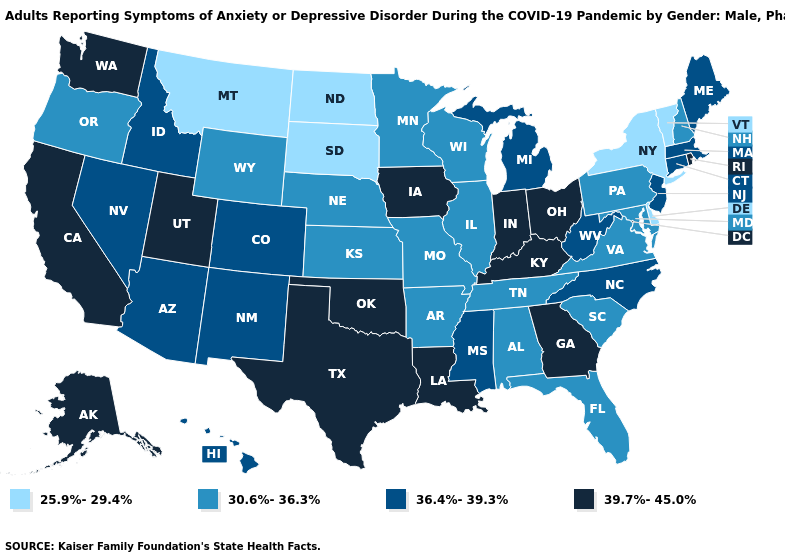What is the value of Florida?
Concise answer only. 30.6%-36.3%. What is the value of Nevada?
Write a very short answer. 36.4%-39.3%. Among the states that border California , which have the lowest value?
Give a very brief answer. Oregon. Does California have the lowest value in the USA?
Short answer required. No. Is the legend a continuous bar?
Quick response, please. No. Which states have the highest value in the USA?
Write a very short answer. Alaska, California, Georgia, Indiana, Iowa, Kentucky, Louisiana, Ohio, Oklahoma, Rhode Island, Texas, Utah, Washington. Does Texas have the lowest value in the USA?
Concise answer only. No. Among the states that border Illinois , does Missouri have the lowest value?
Short answer required. Yes. Which states hav the highest value in the MidWest?
Keep it brief. Indiana, Iowa, Ohio. Among the states that border California , which have the lowest value?
Quick response, please. Oregon. Does the map have missing data?
Keep it brief. No. Is the legend a continuous bar?
Answer briefly. No. What is the lowest value in the South?
Keep it brief. 25.9%-29.4%. Does North Carolina have a lower value than Connecticut?
Short answer required. No. Among the states that border South Carolina , which have the lowest value?
Short answer required. North Carolina. 